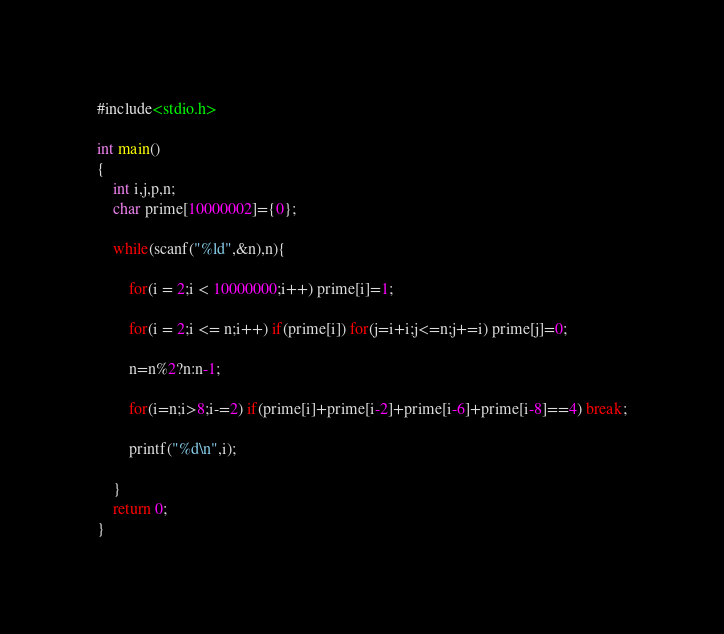<code> <loc_0><loc_0><loc_500><loc_500><_C_>#include<stdio.h>

int main()
{
    int i,j,p,n;
    char prime[10000002]={0};

    while(scanf("%ld",&n),n){

        for(i = 2;i < 10000000;i++) prime[i]=1;

        for(i = 2;i <= n;i++) if(prime[i]) for(j=i+i;j<=n;j+=i) prime[j]=0;

        n=n%2?n:n-1;

        for(i=n;i>8;i-=2) if(prime[i]+prime[i-2]+prime[i-6]+prime[i-8]==4) break;

        printf("%d\n",i);

    }   
    return 0;
}</code> 